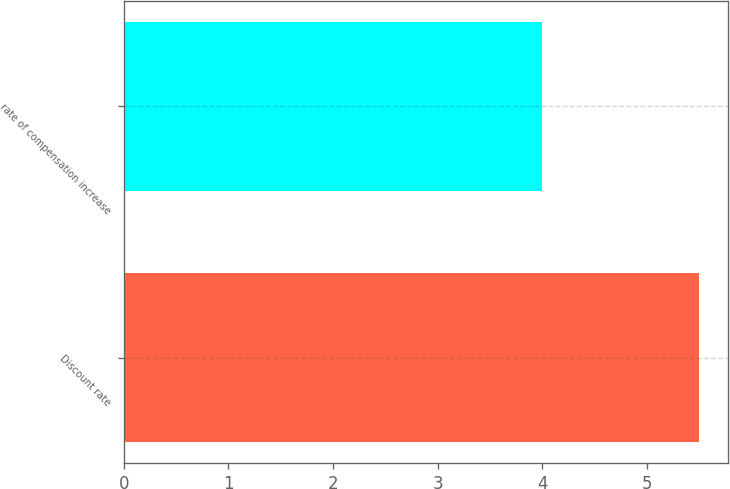<chart> <loc_0><loc_0><loc_500><loc_500><bar_chart><fcel>Discount rate<fcel>rate of compensation increase<nl><fcel>5.5<fcel>4<nl></chart> 